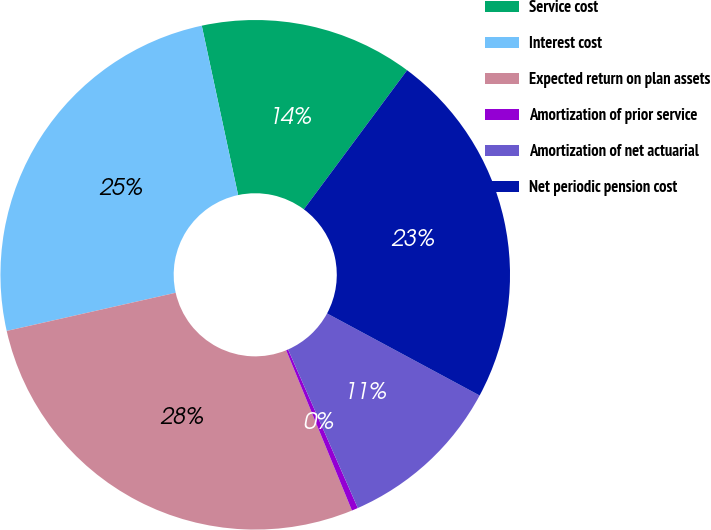Convert chart. <chart><loc_0><loc_0><loc_500><loc_500><pie_chart><fcel>Service cost<fcel>Interest cost<fcel>Expected return on plan assets<fcel>Amortization of prior service<fcel>Amortization of net actuarial<fcel>Net periodic pension cost<nl><fcel>13.53%<fcel>25.17%<fcel>27.66%<fcel>0.4%<fcel>10.55%<fcel>22.69%<nl></chart> 